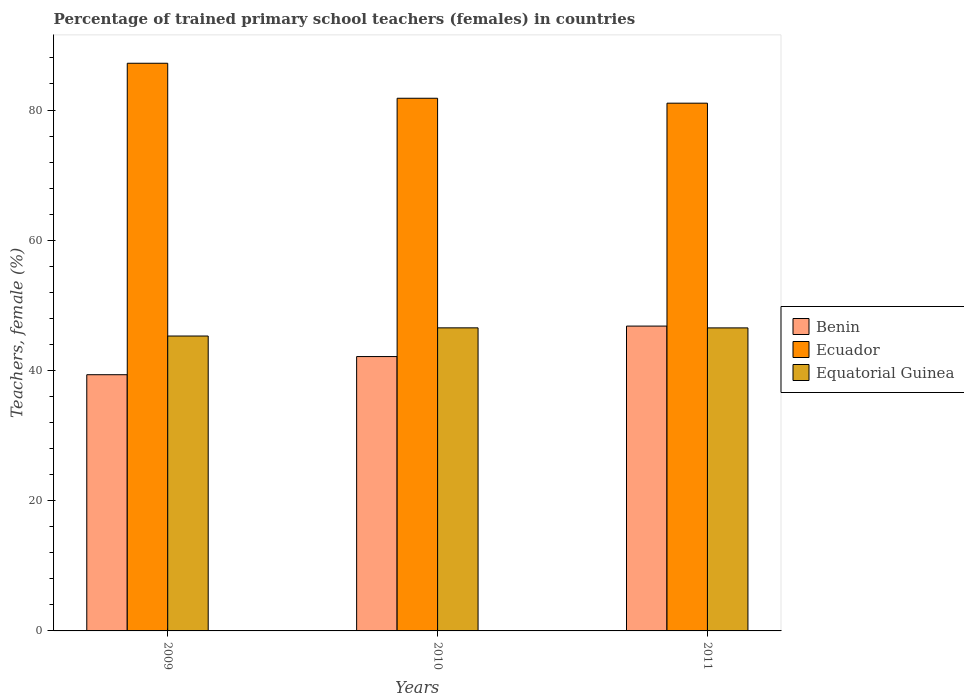What is the label of the 2nd group of bars from the left?
Offer a terse response. 2010. In how many cases, is the number of bars for a given year not equal to the number of legend labels?
Your response must be concise. 0. What is the percentage of trained primary school teachers (females) in Benin in 2011?
Your response must be concise. 46.82. Across all years, what is the maximum percentage of trained primary school teachers (females) in Equatorial Guinea?
Your answer should be very brief. 46.54. Across all years, what is the minimum percentage of trained primary school teachers (females) in Equatorial Guinea?
Offer a terse response. 45.29. In which year was the percentage of trained primary school teachers (females) in Equatorial Guinea maximum?
Your answer should be very brief. 2010. In which year was the percentage of trained primary school teachers (females) in Ecuador minimum?
Ensure brevity in your answer.  2011. What is the total percentage of trained primary school teachers (females) in Equatorial Guinea in the graph?
Your response must be concise. 138.37. What is the difference between the percentage of trained primary school teachers (females) in Benin in 2009 and that in 2010?
Offer a very short reply. -2.79. What is the difference between the percentage of trained primary school teachers (females) in Benin in 2010 and the percentage of trained primary school teachers (females) in Equatorial Guinea in 2009?
Keep it short and to the point. -3.15. What is the average percentage of trained primary school teachers (females) in Ecuador per year?
Provide a short and direct response. 83.35. In the year 2010, what is the difference between the percentage of trained primary school teachers (females) in Ecuador and percentage of trained primary school teachers (females) in Equatorial Guinea?
Offer a terse response. 35.26. What is the ratio of the percentage of trained primary school teachers (females) in Benin in 2010 to that in 2011?
Make the answer very short. 0.9. What is the difference between the highest and the second highest percentage of trained primary school teachers (females) in Benin?
Your answer should be compact. 4.68. What is the difference between the highest and the lowest percentage of trained primary school teachers (females) in Ecuador?
Offer a very short reply. 6.13. In how many years, is the percentage of trained primary school teachers (females) in Benin greater than the average percentage of trained primary school teachers (females) in Benin taken over all years?
Keep it short and to the point. 1. Is the sum of the percentage of trained primary school teachers (females) in Benin in 2009 and 2010 greater than the maximum percentage of trained primary school teachers (females) in Equatorial Guinea across all years?
Provide a succinct answer. Yes. What does the 3rd bar from the left in 2009 represents?
Provide a succinct answer. Equatorial Guinea. What does the 3rd bar from the right in 2009 represents?
Provide a short and direct response. Benin. Are all the bars in the graph horizontal?
Offer a terse response. No. Does the graph contain any zero values?
Make the answer very short. No. Does the graph contain grids?
Offer a terse response. No. Where does the legend appear in the graph?
Provide a short and direct response. Center right. What is the title of the graph?
Your answer should be compact. Percentage of trained primary school teachers (females) in countries. What is the label or title of the Y-axis?
Provide a short and direct response. Teachers, female (%). What is the Teachers, female (%) in Benin in 2009?
Give a very brief answer. 39.35. What is the Teachers, female (%) of Ecuador in 2009?
Keep it short and to the point. 87.18. What is the Teachers, female (%) of Equatorial Guinea in 2009?
Provide a short and direct response. 45.29. What is the Teachers, female (%) in Benin in 2010?
Your answer should be compact. 42.14. What is the Teachers, female (%) of Ecuador in 2010?
Your answer should be very brief. 81.81. What is the Teachers, female (%) in Equatorial Guinea in 2010?
Your response must be concise. 46.54. What is the Teachers, female (%) in Benin in 2011?
Provide a succinct answer. 46.82. What is the Teachers, female (%) of Ecuador in 2011?
Keep it short and to the point. 81.05. What is the Teachers, female (%) of Equatorial Guinea in 2011?
Give a very brief answer. 46.54. Across all years, what is the maximum Teachers, female (%) of Benin?
Provide a succinct answer. 46.82. Across all years, what is the maximum Teachers, female (%) in Ecuador?
Your answer should be very brief. 87.18. Across all years, what is the maximum Teachers, female (%) of Equatorial Guinea?
Offer a very short reply. 46.54. Across all years, what is the minimum Teachers, female (%) in Benin?
Offer a terse response. 39.35. Across all years, what is the minimum Teachers, female (%) of Ecuador?
Make the answer very short. 81.05. Across all years, what is the minimum Teachers, female (%) of Equatorial Guinea?
Give a very brief answer. 45.29. What is the total Teachers, female (%) in Benin in the graph?
Provide a succinct answer. 128.3. What is the total Teachers, female (%) in Ecuador in the graph?
Make the answer very short. 250.04. What is the total Teachers, female (%) of Equatorial Guinea in the graph?
Your response must be concise. 138.37. What is the difference between the Teachers, female (%) of Benin in 2009 and that in 2010?
Offer a very short reply. -2.79. What is the difference between the Teachers, female (%) of Ecuador in 2009 and that in 2010?
Your answer should be compact. 5.38. What is the difference between the Teachers, female (%) of Equatorial Guinea in 2009 and that in 2010?
Your answer should be compact. -1.25. What is the difference between the Teachers, female (%) in Benin in 2009 and that in 2011?
Provide a succinct answer. -7.47. What is the difference between the Teachers, female (%) in Ecuador in 2009 and that in 2011?
Offer a terse response. 6.13. What is the difference between the Teachers, female (%) in Equatorial Guinea in 2009 and that in 2011?
Your response must be concise. -1.25. What is the difference between the Teachers, female (%) of Benin in 2010 and that in 2011?
Provide a short and direct response. -4.68. What is the difference between the Teachers, female (%) in Ecuador in 2010 and that in 2011?
Keep it short and to the point. 0.75. What is the difference between the Teachers, female (%) of Equatorial Guinea in 2010 and that in 2011?
Offer a very short reply. 0.01. What is the difference between the Teachers, female (%) in Benin in 2009 and the Teachers, female (%) in Ecuador in 2010?
Offer a very short reply. -42.46. What is the difference between the Teachers, female (%) in Benin in 2009 and the Teachers, female (%) in Equatorial Guinea in 2010?
Your response must be concise. -7.19. What is the difference between the Teachers, female (%) in Ecuador in 2009 and the Teachers, female (%) in Equatorial Guinea in 2010?
Offer a terse response. 40.64. What is the difference between the Teachers, female (%) of Benin in 2009 and the Teachers, female (%) of Ecuador in 2011?
Offer a very short reply. -41.7. What is the difference between the Teachers, female (%) of Benin in 2009 and the Teachers, female (%) of Equatorial Guinea in 2011?
Make the answer very short. -7.19. What is the difference between the Teachers, female (%) in Ecuador in 2009 and the Teachers, female (%) in Equatorial Guinea in 2011?
Offer a very short reply. 40.64. What is the difference between the Teachers, female (%) in Benin in 2010 and the Teachers, female (%) in Ecuador in 2011?
Provide a succinct answer. -38.91. What is the difference between the Teachers, female (%) of Benin in 2010 and the Teachers, female (%) of Equatorial Guinea in 2011?
Your answer should be very brief. -4.4. What is the difference between the Teachers, female (%) of Ecuador in 2010 and the Teachers, female (%) of Equatorial Guinea in 2011?
Your answer should be very brief. 35.27. What is the average Teachers, female (%) in Benin per year?
Offer a terse response. 42.77. What is the average Teachers, female (%) of Ecuador per year?
Ensure brevity in your answer.  83.35. What is the average Teachers, female (%) of Equatorial Guinea per year?
Your answer should be compact. 46.12. In the year 2009, what is the difference between the Teachers, female (%) of Benin and Teachers, female (%) of Ecuador?
Give a very brief answer. -47.83. In the year 2009, what is the difference between the Teachers, female (%) in Benin and Teachers, female (%) in Equatorial Guinea?
Your answer should be compact. -5.94. In the year 2009, what is the difference between the Teachers, female (%) in Ecuador and Teachers, female (%) in Equatorial Guinea?
Give a very brief answer. 41.89. In the year 2010, what is the difference between the Teachers, female (%) in Benin and Teachers, female (%) in Ecuador?
Give a very brief answer. -39.67. In the year 2010, what is the difference between the Teachers, female (%) of Benin and Teachers, female (%) of Equatorial Guinea?
Keep it short and to the point. -4.41. In the year 2010, what is the difference between the Teachers, female (%) in Ecuador and Teachers, female (%) in Equatorial Guinea?
Make the answer very short. 35.26. In the year 2011, what is the difference between the Teachers, female (%) in Benin and Teachers, female (%) in Ecuador?
Your answer should be compact. -34.23. In the year 2011, what is the difference between the Teachers, female (%) in Benin and Teachers, female (%) in Equatorial Guinea?
Provide a short and direct response. 0.28. In the year 2011, what is the difference between the Teachers, female (%) of Ecuador and Teachers, female (%) of Equatorial Guinea?
Make the answer very short. 34.51. What is the ratio of the Teachers, female (%) in Benin in 2009 to that in 2010?
Make the answer very short. 0.93. What is the ratio of the Teachers, female (%) of Ecuador in 2009 to that in 2010?
Make the answer very short. 1.07. What is the ratio of the Teachers, female (%) of Equatorial Guinea in 2009 to that in 2010?
Ensure brevity in your answer.  0.97. What is the ratio of the Teachers, female (%) in Benin in 2009 to that in 2011?
Give a very brief answer. 0.84. What is the ratio of the Teachers, female (%) of Ecuador in 2009 to that in 2011?
Ensure brevity in your answer.  1.08. What is the ratio of the Teachers, female (%) of Equatorial Guinea in 2009 to that in 2011?
Your response must be concise. 0.97. What is the ratio of the Teachers, female (%) of Benin in 2010 to that in 2011?
Offer a very short reply. 0.9. What is the ratio of the Teachers, female (%) in Ecuador in 2010 to that in 2011?
Give a very brief answer. 1.01. What is the ratio of the Teachers, female (%) in Equatorial Guinea in 2010 to that in 2011?
Offer a terse response. 1. What is the difference between the highest and the second highest Teachers, female (%) of Benin?
Offer a terse response. 4.68. What is the difference between the highest and the second highest Teachers, female (%) in Ecuador?
Provide a succinct answer. 5.38. What is the difference between the highest and the second highest Teachers, female (%) of Equatorial Guinea?
Your response must be concise. 0.01. What is the difference between the highest and the lowest Teachers, female (%) in Benin?
Provide a succinct answer. 7.47. What is the difference between the highest and the lowest Teachers, female (%) in Ecuador?
Offer a very short reply. 6.13. What is the difference between the highest and the lowest Teachers, female (%) in Equatorial Guinea?
Keep it short and to the point. 1.25. 